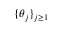<formula> <loc_0><loc_0><loc_500><loc_500>\{ \theta _ { j } \} _ { j \geq 1 }</formula> 